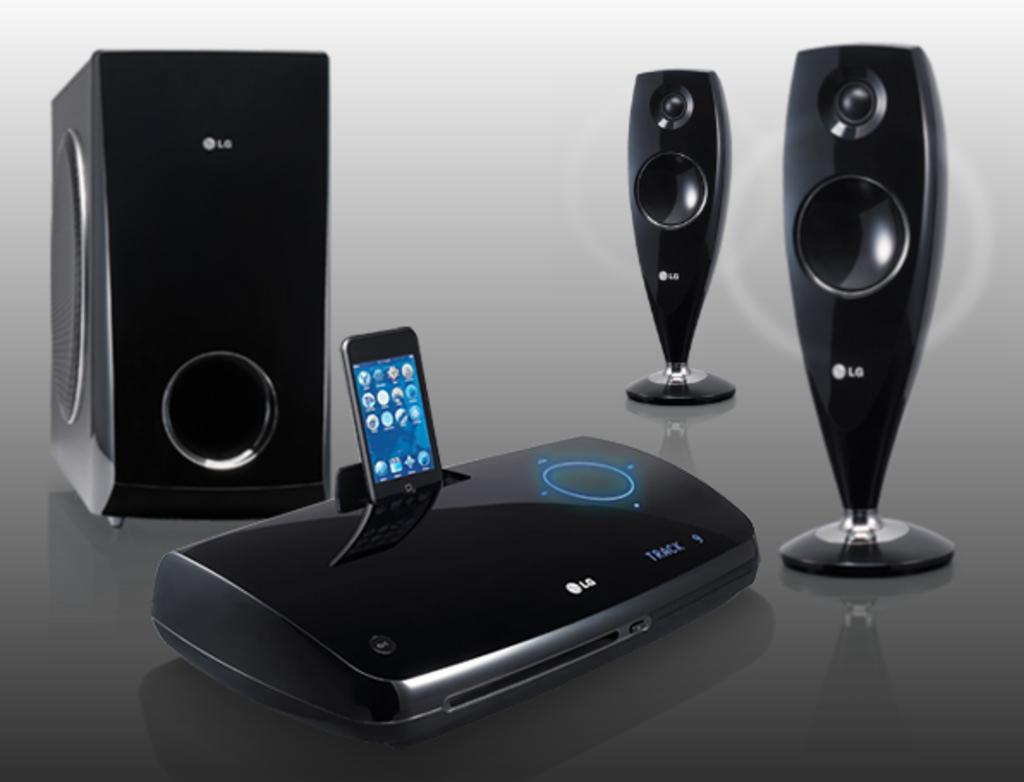Provide a one-sentence caption for the provided image. A black multimedia speaker system with a subwoofer made by LG. 